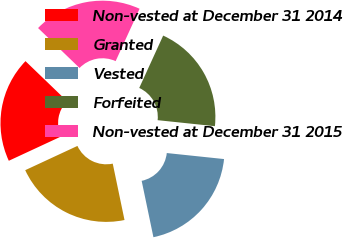Convert chart. <chart><loc_0><loc_0><loc_500><loc_500><pie_chart><fcel>Non-vested at December 31 2014<fcel>Granted<fcel>Vested<fcel>Forfeited<fcel>Non-vested at December 31 2015<nl><fcel>19.12%<fcel>21.35%<fcel>20.06%<fcel>19.84%<fcel>19.62%<nl></chart> 